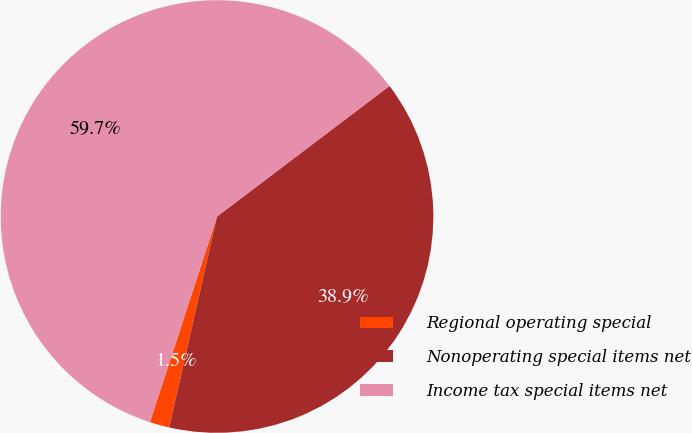<chart> <loc_0><loc_0><loc_500><loc_500><pie_chart><fcel>Regional operating special<fcel>Nonoperating special items net<fcel>Income tax special items net<nl><fcel>1.47%<fcel>38.86%<fcel>59.67%<nl></chart> 